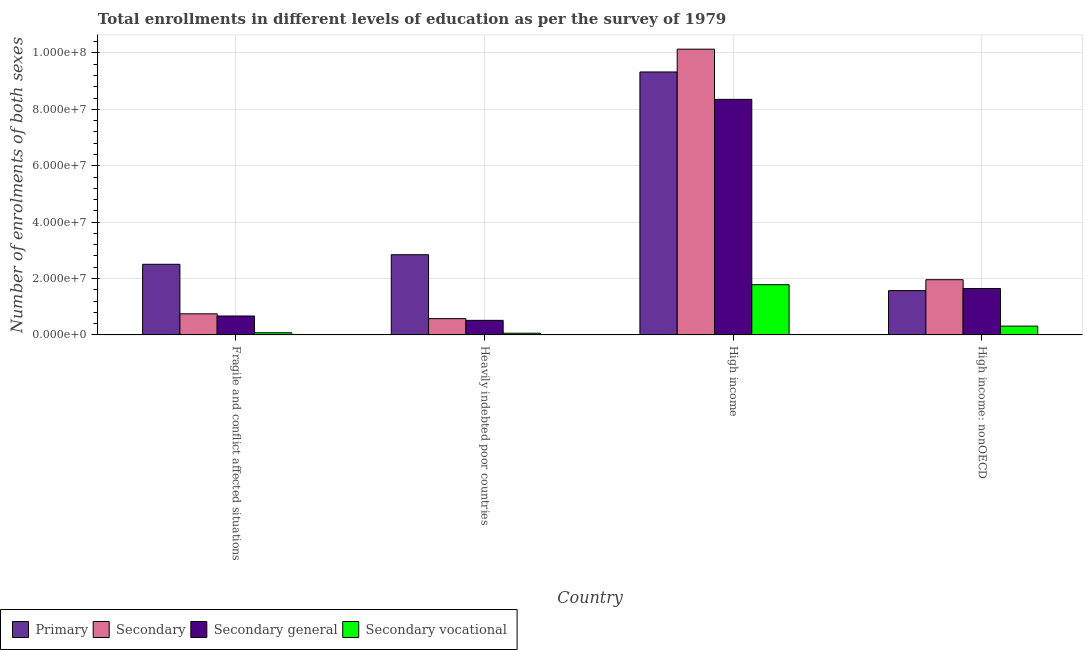How many groups of bars are there?
Provide a succinct answer. 4. Are the number of bars on each tick of the X-axis equal?
Your answer should be compact. Yes. How many bars are there on the 4th tick from the left?
Your answer should be compact. 4. How many bars are there on the 4th tick from the right?
Keep it short and to the point. 4. What is the label of the 2nd group of bars from the left?
Provide a short and direct response. Heavily indebted poor countries. What is the number of enrolments in primary education in Fragile and conflict affected situations?
Give a very brief answer. 2.51e+07. Across all countries, what is the maximum number of enrolments in secondary education?
Offer a terse response. 1.01e+08. Across all countries, what is the minimum number of enrolments in secondary general education?
Offer a terse response. 5.17e+06. In which country was the number of enrolments in secondary vocational education maximum?
Your response must be concise. High income. In which country was the number of enrolments in primary education minimum?
Keep it short and to the point. High income: nonOECD. What is the total number of enrolments in secondary vocational education in the graph?
Your response must be concise. 2.23e+07. What is the difference between the number of enrolments in primary education in Heavily indebted poor countries and that in High income: nonOECD?
Keep it short and to the point. 1.27e+07. What is the difference between the number of enrolments in secondary general education in Heavily indebted poor countries and the number of enrolments in secondary vocational education in High income?
Keep it short and to the point. -1.26e+07. What is the average number of enrolments in primary education per country?
Your response must be concise. 4.06e+07. What is the difference between the number of enrolments in secondary general education and number of enrolments in primary education in Heavily indebted poor countries?
Keep it short and to the point. -2.33e+07. In how many countries, is the number of enrolments in primary education greater than 36000000 ?
Give a very brief answer. 1. What is the ratio of the number of enrolments in secondary education in Heavily indebted poor countries to that in High income?
Provide a succinct answer. 0.06. Is the number of enrolments in primary education in High income less than that in High income: nonOECD?
Your response must be concise. No. Is the difference between the number of enrolments in primary education in Heavily indebted poor countries and High income greater than the difference between the number of enrolments in secondary education in Heavily indebted poor countries and High income?
Provide a succinct answer. Yes. What is the difference between the highest and the second highest number of enrolments in secondary general education?
Keep it short and to the point. 6.71e+07. What is the difference between the highest and the lowest number of enrolments in secondary education?
Keep it short and to the point. 9.56e+07. In how many countries, is the number of enrolments in primary education greater than the average number of enrolments in primary education taken over all countries?
Your response must be concise. 1. Is the sum of the number of enrolments in primary education in Fragile and conflict affected situations and Heavily indebted poor countries greater than the maximum number of enrolments in secondary general education across all countries?
Offer a very short reply. No. What does the 4th bar from the left in High income: nonOECD represents?
Your answer should be very brief. Secondary vocational. What does the 3rd bar from the right in High income represents?
Make the answer very short. Secondary. Is it the case that in every country, the sum of the number of enrolments in primary education and number of enrolments in secondary education is greater than the number of enrolments in secondary general education?
Your answer should be compact. Yes. What is the difference between two consecutive major ticks on the Y-axis?
Provide a short and direct response. 2.00e+07. Are the values on the major ticks of Y-axis written in scientific E-notation?
Offer a terse response. Yes. Does the graph contain any zero values?
Your answer should be very brief. No. Where does the legend appear in the graph?
Provide a succinct answer. Bottom left. How are the legend labels stacked?
Provide a short and direct response. Horizontal. What is the title of the graph?
Your response must be concise. Total enrollments in different levels of education as per the survey of 1979. What is the label or title of the Y-axis?
Your answer should be compact. Number of enrolments of both sexes. What is the Number of enrolments of both sexes in Primary in Fragile and conflict affected situations?
Give a very brief answer. 2.51e+07. What is the Number of enrolments of both sexes of Secondary in Fragile and conflict affected situations?
Your answer should be compact. 7.48e+06. What is the Number of enrolments of both sexes of Secondary general in Fragile and conflict affected situations?
Give a very brief answer. 6.71e+06. What is the Number of enrolments of both sexes of Secondary vocational in Fragile and conflict affected situations?
Offer a very short reply. 7.72e+05. What is the Number of enrolments of both sexes in Primary in Heavily indebted poor countries?
Make the answer very short. 2.84e+07. What is the Number of enrolments of both sexes of Secondary in Heavily indebted poor countries?
Provide a short and direct response. 5.77e+06. What is the Number of enrolments of both sexes of Secondary general in Heavily indebted poor countries?
Your answer should be compact. 5.17e+06. What is the Number of enrolments of both sexes in Secondary vocational in Heavily indebted poor countries?
Offer a terse response. 6.01e+05. What is the Number of enrolments of both sexes of Primary in High income?
Your answer should be compact. 9.33e+07. What is the Number of enrolments of both sexes of Secondary in High income?
Keep it short and to the point. 1.01e+08. What is the Number of enrolments of both sexes of Secondary general in High income?
Ensure brevity in your answer.  8.35e+07. What is the Number of enrolments of both sexes of Secondary vocational in High income?
Provide a succinct answer. 1.78e+07. What is the Number of enrolments of both sexes of Primary in High income: nonOECD?
Give a very brief answer. 1.57e+07. What is the Number of enrolments of both sexes of Secondary in High income: nonOECD?
Give a very brief answer. 1.96e+07. What is the Number of enrolments of both sexes in Secondary general in High income: nonOECD?
Give a very brief answer. 1.65e+07. What is the Number of enrolments of both sexes in Secondary vocational in High income: nonOECD?
Your answer should be compact. 3.12e+06. Across all countries, what is the maximum Number of enrolments of both sexes of Primary?
Ensure brevity in your answer.  9.33e+07. Across all countries, what is the maximum Number of enrolments of both sexes in Secondary?
Your answer should be very brief. 1.01e+08. Across all countries, what is the maximum Number of enrolments of both sexes in Secondary general?
Ensure brevity in your answer.  8.35e+07. Across all countries, what is the maximum Number of enrolments of both sexes of Secondary vocational?
Your answer should be very brief. 1.78e+07. Across all countries, what is the minimum Number of enrolments of both sexes of Primary?
Your answer should be compact. 1.57e+07. Across all countries, what is the minimum Number of enrolments of both sexes in Secondary?
Keep it short and to the point. 5.77e+06. Across all countries, what is the minimum Number of enrolments of both sexes in Secondary general?
Provide a short and direct response. 5.17e+06. Across all countries, what is the minimum Number of enrolments of both sexes in Secondary vocational?
Make the answer very short. 6.01e+05. What is the total Number of enrolments of both sexes in Primary in the graph?
Offer a very short reply. 1.62e+08. What is the total Number of enrolments of both sexes of Secondary in the graph?
Provide a short and direct response. 1.34e+08. What is the total Number of enrolments of both sexes in Secondary general in the graph?
Offer a very short reply. 1.12e+08. What is the total Number of enrolments of both sexes in Secondary vocational in the graph?
Offer a very short reply. 2.23e+07. What is the difference between the Number of enrolments of both sexes in Primary in Fragile and conflict affected situations and that in Heavily indebted poor countries?
Make the answer very short. -3.39e+06. What is the difference between the Number of enrolments of both sexes of Secondary in Fragile and conflict affected situations and that in Heavily indebted poor countries?
Provide a succinct answer. 1.71e+06. What is the difference between the Number of enrolments of both sexes of Secondary general in Fragile and conflict affected situations and that in Heavily indebted poor countries?
Offer a very short reply. 1.54e+06. What is the difference between the Number of enrolments of both sexes of Secondary vocational in Fragile and conflict affected situations and that in Heavily indebted poor countries?
Provide a short and direct response. 1.71e+05. What is the difference between the Number of enrolments of both sexes of Primary in Fragile and conflict affected situations and that in High income?
Your response must be concise. -6.82e+07. What is the difference between the Number of enrolments of both sexes in Secondary in Fragile and conflict affected situations and that in High income?
Ensure brevity in your answer.  -9.39e+07. What is the difference between the Number of enrolments of both sexes in Secondary general in Fragile and conflict affected situations and that in High income?
Give a very brief answer. -7.68e+07. What is the difference between the Number of enrolments of both sexes of Secondary vocational in Fragile and conflict affected situations and that in High income?
Offer a very short reply. -1.70e+07. What is the difference between the Number of enrolments of both sexes in Primary in Fragile and conflict affected situations and that in High income: nonOECD?
Offer a very short reply. 9.34e+06. What is the difference between the Number of enrolments of both sexes of Secondary in Fragile and conflict affected situations and that in High income: nonOECD?
Your answer should be compact. -1.21e+07. What is the difference between the Number of enrolments of both sexes of Secondary general in Fragile and conflict affected situations and that in High income: nonOECD?
Offer a terse response. -9.76e+06. What is the difference between the Number of enrolments of both sexes of Secondary vocational in Fragile and conflict affected situations and that in High income: nonOECD?
Give a very brief answer. -2.35e+06. What is the difference between the Number of enrolments of both sexes of Primary in Heavily indebted poor countries and that in High income?
Your answer should be very brief. -6.48e+07. What is the difference between the Number of enrolments of both sexes of Secondary in Heavily indebted poor countries and that in High income?
Your answer should be compact. -9.56e+07. What is the difference between the Number of enrolments of both sexes in Secondary general in Heavily indebted poor countries and that in High income?
Make the answer very short. -7.84e+07. What is the difference between the Number of enrolments of both sexes in Secondary vocational in Heavily indebted poor countries and that in High income?
Provide a short and direct response. -1.72e+07. What is the difference between the Number of enrolments of both sexes of Primary in Heavily indebted poor countries and that in High income: nonOECD?
Make the answer very short. 1.27e+07. What is the difference between the Number of enrolments of both sexes in Secondary in Heavily indebted poor countries and that in High income: nonOECD?
Give a very brief answer. -1.38e+07. What is the difference between the Number of enrolments of both sexes in Secondary general in Heavily indebted poor countries and that in High income: nonOECD?
Give a very brief answer. -1.13e+07. What is the difference between the Number of enrolments of both sexes of Secondary vocational in Heavily indebted poor countries and that in High income: nonOECD?
Ensure brevity in your answer.  -2.52e+06. What is the difference between the Number of enrolments of both sexes of Primary in High income and that in High income: nonOECD?
Keep it short and to the point. 7.76e+07. What is the difference between the Number of enrolments of both sexes of Secondary in High income and that in High income: nonOECD?
Ensure brevity in your answer.  8.18e+07. What is the difference between the Number of enrolments of both sexes in Secondary general in High income and that in High income: nonOECD?
Provide a short and direct response. 6.71e+07. What is the difference between the Number of enrolments of both sexes in Secondary vocational in High income and that in High income: nonOECD?
Make the answer very short. 1.47e+07. What is the difference between the Number of enrolments of both sexes in Primary in Fragile and conflict affected situations and the Number of enrolments of both sexes in Secondary in Heavily indebted poor countries?
Your answer should be compact. 1.93e+07. What is the difference between the Number of enrolments of both sexes of Primary in Fragile and conflict affected situations and the Number of enrolments of both sexes of Secondary general in Heavily indebted poor countries?
Provide a short and direct response. 1.99e+07. What is the difference between the Number of enrolments of both sexes of Primary in Fragile and conflict affected situations and the Number of enrolments of both sexes of Secondary vocational in Heavily indebted poor countries?
Ensure brevity in your answer.  2.44e+07. What is the difference between the Number of enrolments of both sexes in Secondary in Fragile and conflict affected situations and the Number of enrolments of both sexes in Secondary general in Heavily indebted poor countries?
Offer a terse response. 2.32e+06. What is the difference between the Number of enrolments of both sexes of Secondary in Fragile and conflict affected situations and the Number of enrolments of both sexes of Secondary vocational in Heavily indebted poor countries?
Ensure brevity in your answer.  6.88e+06. What is the difference between the Number of enrolments of both sexes in Secondary general in Fragile and conflict affected situations and the Number of enrolments of both sexes in Secondary vocational in Heavily indebted poor countries?
Make the answer very short. 6.11e+06. What is the difference between the Number of enrolments of both sexes of Primary in Fragile and conflict affected situations and the Number of enrolments of both sexes of Secondary in High income?
Provide a succinct answer. -7.63e+07. What is the difference between the Number of enrolments of both sexes of Primary in Fragile and conflict affected situations and the Number of enrolments of both sexes of Secondary general in High income?
Your answer should be very brief. -5.85e+07. What is the difference between the Number of enrolments of both sexes of Primary in Fragile and conflict affected situations and the Number of enrolments of both sexes of Secondary vocational in High income?
Keep it short and to the point. 7.24e+06. What is the difference between the Number of enrolments of both sexes of Secondary in Fragile and conflict affected situations and the Number of enrolments of both sexes of Secondary general in High income?
Keep it short and to the point. -7.61e+07. What is the difference between the Number of enrolments of both sexes of Secondary in Fragile and conflict affected situations and the Number of enrolments of both sexes of Secondary vocational in High income?
Provide a succinct answer. -1.03e+07. What is the difference between the Number of enrolments of both sexes of Secondary general in Fragile and conflict affected situations and the Number of enrolments of both sexes of Secondary vocational in High income?
Provide a short and direct response. -1.11e+07. What is the difference between the Number of enrolments of both sexes of Primary in Fragile and conflict affected situations and the Number of enrolments of both sexes of Secondary in High income: nonOECD?
Make the answer very short. 5.46e+06. What is the difference between the Number of enrolments of both sexes in Primary in Fragile and conflict affected situations and the Number of enrolments of both sexes in Secondary general in High income: nonOECD?
Your answer should be compact. 8.59e+06. What is the difference between the Number of enrolments of both sexes in Primary in Fragile and conflict affected situations and the Number of enrolments of both sexes in Secondary vocational in High income: nonOECD?
Your answer should be very brief. 2.19e+07. What is the difference between the Number of enrolments of both sexes in Secondary in Fragile and conflict affected situations and the Number of enrolments of both sexes in Secondary general in High income: nonOECD?
Make the answer very short. -8.98e+06. What is the difference between the Number of enrolments of both sexes of Secondary in Fragile and conflict affected situations and the Number of enrolments of both sexes of Secondary vocational in High income: nonOECD?
Your answer should be very brief. 4.36e+06. What is the difference between the Number of enrolments of both sexes in Secondary general in Fragile and conflict affected situations and the Number of enrolments of both sexes in Secondary vocational in High income: nonOECD?
Your answer should be very brief. 3.59e+06. What is the difference between the Number of enrolments of both sexes of Primary in Heavily indebted poor countries and the Number of enrolments of both sexes of Secondary in High income?
Your response must be concise. -7.29e+07. What is the difference between the Number of enrolments of both sexes of Primary in Heavily indebted poor countries and the Number of enrolments of both sexes of Secondary general in High income?
Ensure brevity in your answer.  -5.51e+07. What is the difference between the Number of enrolments of both sexes in Primary in Heavily indebted poor countries and the Number of enrolments of both sexes in Secondary vocational in High income?
Offer a very short reply. 1.06e+07. What is the difference between the Number of enrolments of both sexes in Secondary in Heavily indebted poor countries and the Number of enrolments of both sexes in Secondary general in High income?
Make the answer very short. -7.78e+07. What is the difference between the Number of enrolments of both sexes in Secondary in Heavily indebted poor countries and the Number of enrolments of both sexes in Secondary vocational in High income?
Provide a succinct answer. -1.20e+07. What is the difference between the Number of enrolments of both sexes in Secondary general in Heavily indebted poor countries and the Number of enrolments of both sexes in Secondary vocational in High income?
Provide a succinct answer. -1.26e+07. What is the difference between the Number of enrolments of both sexes in Primary in Heavily indebted poor countries and the Number of enrolments of both sexes in Secondary in High income: nonOECD?
Provide a succinct answer. 8.86e+06. What is the difference between the Number of enrolments of both sexes of Primary in Heavily indebted poor countries and the Number of enrolments of both sexes of Secondary general in High income: nonOECD?
Keep it short and to the point. 1.20e+07. What is the difference between the Number of enrolments of both sexes in Primary in Heavily indebted poor countries and the Number of enrolments of both sexes in Secondary vocational in High income: nonOECD?
Offer a terse response. 2.53e+07. What is the difference between the Number of enrolments of both sexes in Secondary in Heavily indebted poor countries and the Number of enrolments of both sexes in Secondary general in High income: nonOECD?
Offer a very short reply. -1.07e+07. What is the difference between the Number of enrolments of both sexes in Secondary in Heavily indebted poor countries and the Number of enrolments of both sexes in Secondary vocational in High income: nonOECD?
Make the answer very short. 2.64e+06. What is the difference between the Number of enrolments of both sexes of Secondary general in Heavily indebted poor countries and the Number of enrolments of both sexes of Secondary vocational in High income: nonOECD?
Make the answer very short. 2.04e+06. What is the difference between the Number of enrolments of both sexes in Primary in High income and the Number of enrolments of both sexes in Secondary in High income: nonOECD?
Provide a succinct answer. 7.37e+07. What is the difference between the Number of enrolments of both sexes in Primary in High income and the Number of enrolments of both sexes in Secondary general in High income: nonOECD?
Make the answer very short. 7.68e+07. What is the difference between the Number of enrolments of both sexes in Primary in High income and the Number of enrolments of both sexes in Secondary vocational in High income: nonOECD?
Your answer should be compact. 9.01e+07. What is the difference between the Number of enrolments of both sexes in Secondary in High income and the Number of enrolments of both sexes in Secondary general in High income: nonOECD?
Offer a terse response. 8.49e+07. What is the difference between the Number of enrolments of both sexes in Secondary in High income and the Number of enrolments of both sexes in Secondary vocational in High income: nonOECD?
Give a very brief answer. 9.82e+07. What is the difference between the Number of enrolments of both sexes of Secondary general in High income and the Number of enrolments of both sexes of Secondary vocational in High income: nonOECD?
Your response must be concise. 8.04e+07. What is the average Number of enrolments of both sexes of Primary per country?
Offer a very short reply. 4.06e+07. What is the average Number of enrolments of both sexes in Secondary per country?
Your response must be concise. 3.35e+07. What is the average Number of enrolments of both sexes of Secondary general per country?
Provide a short and direct response. 2.80e+07. What is the average Number of enrolments of both sexes in Secondary vocational per country?
Keep it short and to the point. 5.58e+06. What is the difference between the Number of enrolments of both sexes in Primary and Number of enrolments of both sexes in Secondary in Fragile and conflict affected situations?
Give a very brief answer. 1.76e+07. What is the difference between the Number of enrolments of both sexes of Primary and Number of enrolments of both sexes of Secondary general in Fragile and conflict affected situations?
Make the answer very short. 1.83e+07. What is the difference between the Number of enrolments of both sexes in Primary and Number of enrolments of both sexes in Secondary vocational in Fragile and conflict affected situations?
Keep it short and to the point. 2.43e+07. What is the difference between the Number of enrolments of both sexes of Secondary and Number of enrolments of both sexes of Secondary general in Fragile and conflict affected situations?
Your answer should be very brief. 7.72e+05. What is the difference between the Number of enrolments of both sexes in Secondary and Number of enrolments of both sexes in Secondary vocational in Fragile and conflict affected situations?
Keep it short and to the point. 6.71e+06. What is the difference between the Number of enrolments of both sexes of Secondary general and Number of enrolments of both sexes of Secondary vocational in Fragile and conflict affected situations?
Offer a very short reply. 5.94e+06. What is the difference between the Number of enrolments of both sexes of Primary and Number of enrolments of both sexes of Secondary in Heavily indebted poor countries?
Your answer should be very brief. 2.27e+07. What is the difference between the Number of enrolments of both sexes of Primary and Number of enrolments of both sexes of Secondary general in Heavily indebted poor countries?
Ensure brevity in your answer.  2.33e+07. What is the difference between the Number of enrolments of both sexes of Primary and Number of enrolments of both sexes of Secondary vocational in Heavily indebted poor countries?
Make the answer very short. 2.78e+07. What is the difference between the Number of enrolments of both sexes of Secondary and Number of enrolments of both sexes of Secondary general in Heavily indebted poor countries?
Your answer should be compact. 6.01e+05. What is the difference between the Number of enrolments of both sexes of Secondary and Number of enrolments of both sexes of Secondary vocational in Heavily indebted poor countries?
Provide a succinct answer. 5.17e+06. What is the difference between the Number of enrolments of both sexes of Secondary general and Number of enrolments of both sexes of Secondary vocational in Heavily indebted poor countries?
Your answer should be compact. 4.57e+06. What is the difference between the Number of enrolments of both sexes in Primary and Number of enrolments of both sexes in Secondary in High income?
Give a very brief answer. -8.09e+06. What is the difference between the Number of enrolments of both sexes of Primary and Number of enrolments of both sexes of Secondary general in High income?
Provide a succinct answer. 9.72e+06. What is the difference between the Number of enrolments of both sexes in Primary and Number of enrolments of both sexes in Secondary vocational in High income?
Your answer should be compact. 7.55e+07. What is the difference between the Number of enrolments of both sexes of Secondary and Number of enrolments of both sexes of Secondary general in High income?
Provide a succinct answer. 1.78e+07. What is the difference between the Number of enrolments of both sexes in Secondary and Number of enrolments of both sexes in Secondary vocational in High income?
Give a very brief answer. 8.35e+07. What is the difference between the Number of enrolments of both sexes of Secondary general and Number of enrolments of both sexes of Secondary vocational in High income?
Keep it short and to the point. 6.57e+07. What is the difference between the Number of enrolments of both sexes of Primary and Number of enrolments of both sexes of Secondary in High income: nonOECD?
Provide a short and direct response. -3.88e+06. What is the difference between the Number of enrolments of both sexes in Primary and Number of enrolments of both sexes in Secondary general in High income: nonOECD?
Offer a terse response. -7.54e+05. What is the difference between the Number of enrolments of both sexes in Primary and Number of enrolments of both sexes in Secondary vocational in High income: nonOECD?
Your response must be concise. 1.26e+07. What is the difference between the Number of enrolments of both sexes in Secondary and Number of enrolments of both sexes in Secondary general in High income: nonOECD?
Your response must be concise. 3.12e+06. What is the difference between the Number of enrolments of both sexes in Secondary and Number of enrolments of both sexes in Secondary vocational in High income: nonOECD?
Keep it short and to the point. 1.65e+07. What is the difference between the Number of enrolments of both sexes of Secondary general and Number of enrolments of both sexes of Secondary vocational in High income: nonOECD?
Your response must be concise. 1.33e+07. What is the ratio of the Number of enrolments of both sexes in Primary in Fragile and conflict affected situations to that in Heavily indebted poor countries?
Your answer should be compact. 0.88. What is the ratio of the Number of enrolments of both sexes in Secondary in Fragile and conflict affected situations to that in Heavily indebted poor countries?
Your answer should be very brief. 1.3. What is the ratio of the Number of enrolments of both sexes of Secondary general in Fragile and conflict affected situations to that in Heavily indebted poor countries?
Give a very brief answer. 1.3. What is the ratio of the Number of enrolments of both sexes in Secondary vocational in Fragile and conflict affected situations to that in Heavily indebted poor countries?
Provide a succinct answer. 1.29. What is the ratio of the Number of enrolments of both sexes of Primary in Fragile and conflict affected situations to that in High income?
Give a very brief answer. 0.27. What is the ratio of the Number of enrolments of both sexes in Secondary in Fragile and conflict affected situations to that in High income?
Ensure brevity in your answer.  0.07. What is the ratio of the Number of enrolments of both sexes in Secondary general in Fragile and conflict affected situations to that in High income?
Your answer should be compact. 0.08. What is the ratio of the Number of enrolments of both sexes in Secondary vocational in Fragile and conflict affected situations to that in High income?
Give a very brief answer. 0.04. What is the ratio of the Number of enrolments of both sexes of Primary in Fragile and conflict affected situations to that in High income: nonOECD?
Provide a short and direct response. 1.59. What is the ratio of the Number of enrolments of both sexes in Secondary in Fragile and conflict affected situations to that in High income: nonOECD?
Ensure brevity in your answer.  0.38. What is the ratio of the Number of enrolments of both sexes in Secondary general in Fragile and conflict affected situations to that in High income: nonOECD?
Your answer should be compact. 0.41. What is the ratio of the Number of enrolments of both sexes of Secondary vocational in Fragile and conflict affected situations to that in High income: nonOECD?
Provide a short and direct response. 0.25. What is the ratio of the Number of enrolments of both sexes in Primary in Heavily indebted poor countries to that in High income?
Your response must be concise. 0.3. What is the ratio of the Number of enrolments of both sexes of Secondary in Heavily indebted poor countries to that in High income?
Ensure brevity in your answer.  0.06. What is the ratio of the Number of enrolments of both sexes of Secondary general in Heavily indebted poor countries to that in High income?
Give a very brief answer. 0.06. What is the ratio of the Number of enrolments of both sexes of Secondary vocational in Heavily indebted poor countries to that in High income?
Your response must be concise. 0.03. What is the ratio of the Number of enrolments of both sexes in Primary in Heavily indebted poor countries to that in High income: nonOECD?
Ensure brevity in your answer.  1.81. What is the ratio of the Number of enrolments of both sexes of Secondary in Heavily indebted poor countries to that in High income: nonOECD?
Your answer should be compact. 0.29. What is the ratio of the Number of enrolments of both sexes of Secondary general in Heavily indebted poor countries to that in High income: nonOECD?
Provide a succinct answer. 0.31. What is the ratio of the Number of enrolments of both sexes of Secondary vocational in Heavily indebted poor countries to that in High income: nonOECD?
Your response must be concise. 0.19. What is the ratio of the Number of enrolments of both sexes in Primary in High income to that in High income: nonOECD?
Make the answer very short. 5.94. What is the ratio of the Number of enrolments of both sexes of Secondary in High income to that in High income: nonOECD?
Your response must be concise. 5.17. What is the ratio of the Number of enrolments of both sexes of Secondary general in High income to that in High income: nonOECD?
Your answer should be compact. 5.07. What is the ratio of the Number of enrolments of both sexes in Secondary vocational in High income to that in High income: nonOECD?
Your answer should be compact. 5.7. What is the difference between the highest and the second highest Number of enrolments of both sexes in Primary?
Ensure brevity in your answer.  6.48e+07. What is the difference between the highest and the second highest Number of enrolments of both sexes of Secondary?
Offer a terse response. 8.18e+07. What is the difference between the highest and the second highest Number of enrolments of both sexes in Secondary general?
Your response must be concise. 6.71e+07. What is the difference between the highest and the second highest Number of enrolments of both sexes of Secondary vocational?
Provide a short and direct response. 1.47e+07. What is the difference between the highest and the lowest Number of enrolments of both sexes in Primary?
Your answer should be compact. 7.76e+07. What is the difference between the highest and the lowest Number of enrolments of both sexes of Secondary?
Your answer should be compact. 9.56e+07. What is the difference between the highest and the lowest Number of enrolments of both sexes in Secondary general?
Your answer should be compact. 7.84e+07. What is the difference between the highest and the lowest Number of enrolments of both sexes of Secondary vocational?
Your response must be concise. 1.72e+07. 